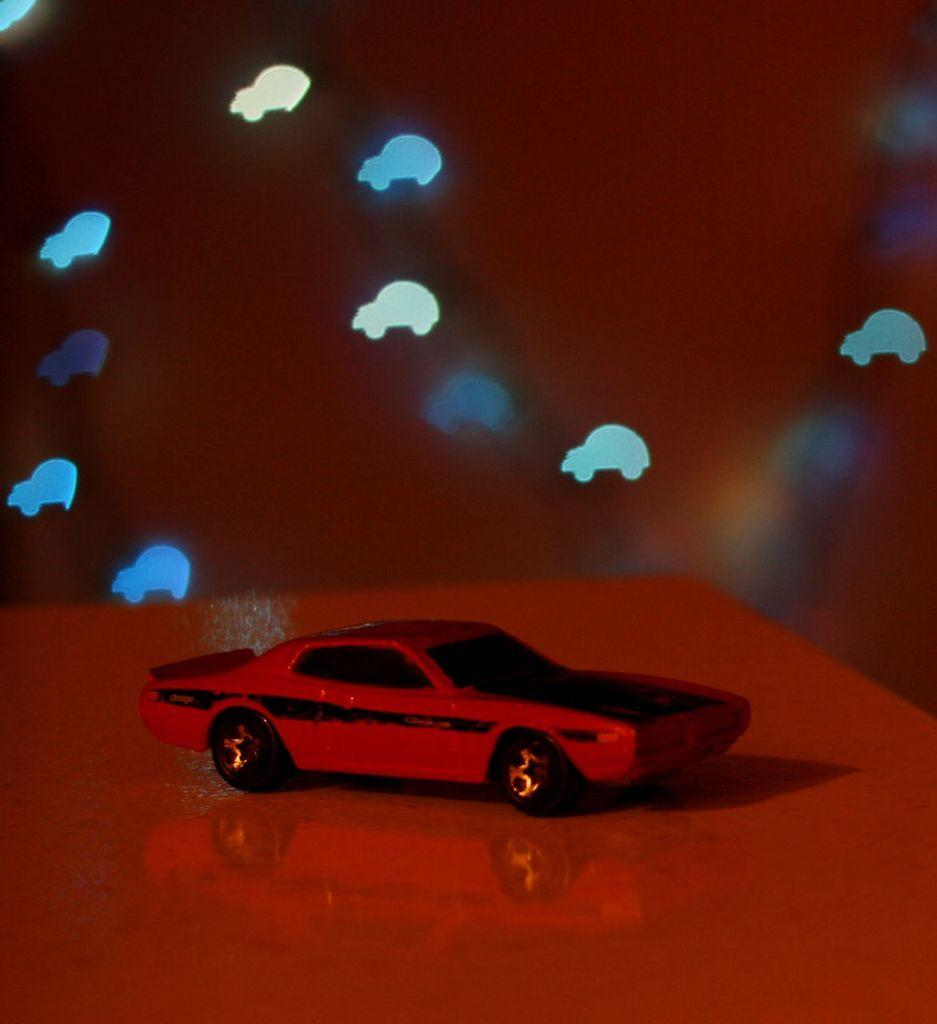What is the main object in the foreground of the image? There is a toy car in the foreground of the image. What can be seen in the background of the image? There are car stickers in the background of the image. Where is the balloon located in the image? There is no balloon present in the image. What type of crown can be seen on the toy car in the image? There is no crown present on the toy car in the image. 